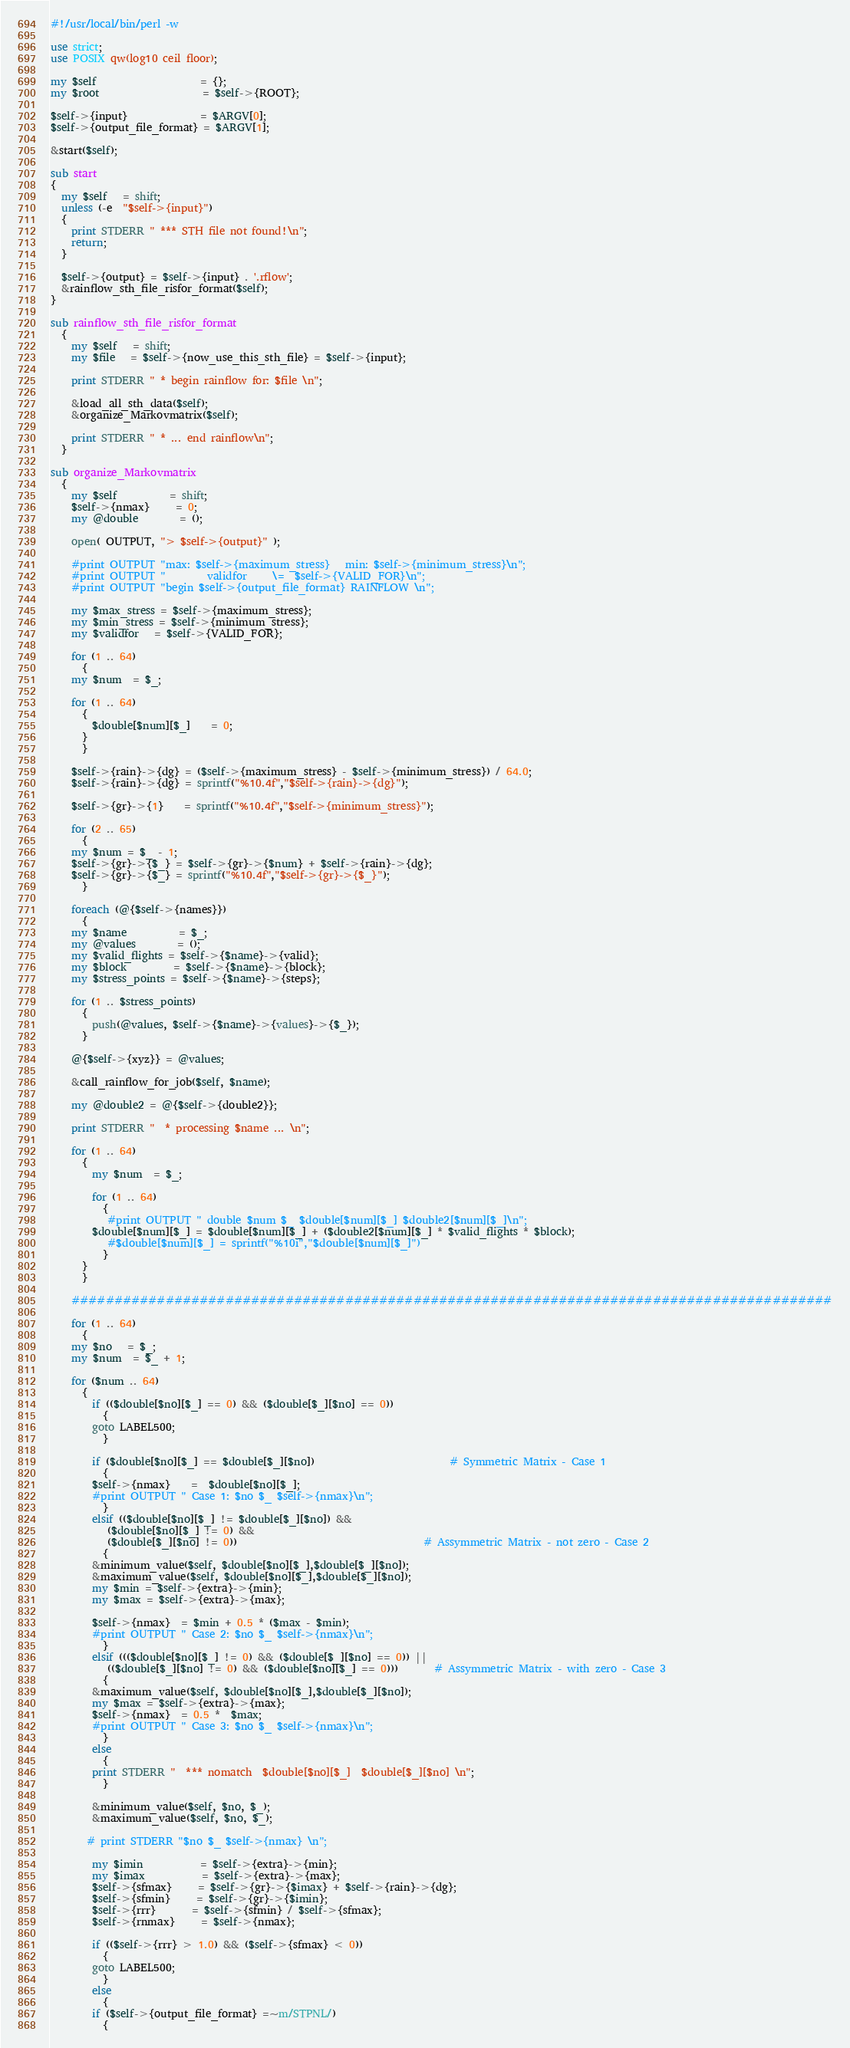Convert code to text. <code><loc_0><loc_0><loc_500><loc_500><_Perl_>#!/usr/local/bin/perl -w

use strict;
use POSIX qw(log10 ceil floor);

my $self                    = {};
my $root                    = $self->{ROOT};

$self->{input}              = $ARGV[0];
$self->{output_file_format} = $ARGV[1];

&start($self);

sub start
{
  my $self   = shift;
  unless (-e  "$self->{input}")
  {
    print STDERR " *** STH file not found!\n";
    return;
  }
  
  $self->{output} = $self->{input} . '.rflow';
  &rainflow_sth_file_risfor_format($self);
}

sub rainflow_sth_file_risfor_format
  {
    my $self   = shift;
    my $file   = $self->{now_use_this_sth_file} = $self->{input};

    print STDERR " * begin rainflow for: $file \n";

    &load_all_sth_data($self);
    &organize_Markovmatrix($self);

    print STDERR " * ... end rainflow\n";
  }

sub organize_Markovmatrix
  {
    my $self          = shift;
    $self->{nmax}     = 0;
    my @double        = ();

    open( OUTPUT, "> $self->{output}" );

    #print OUTPUT "max: $self->{maximum_stress}   min: $self->{minimum_stress}\n";
    #print OUTPUT "        validfor     \=  $self->{VALID_FOR}\n";
    #print OUTPUT "begin $self->{output_file_format} RAINFLOW \n";

    my $max_stress = $self->{maximum_stress};
    my $min_stress = $self->{minimum_stress};
    my $validfor   = $self->{VALID_FOR};

    for (1 .. 64)
      {
	my $num  = $_;

	for (1 .. 64)
	  {
	    $double[$num][$_]    = 0;
	  }
      }

    $self->{rain}->{dg} = ($self->{maximum_stress} - $self->{minimum_stress}) / 64.0;
    $self->{rain}->{dg} = sprintf("%10.4f","$self->{rain}->{dg}");

    $self->{gr}->{1}    = sprintf("%10.4f","$self->{minimum_stress}");

    for (2 .. 65)
      {
	my $num = $_ - 1;
	$self->{gr}->{$_} = $self->{gr}->{$num} + $self->{rain}->{dg};
	$self->{gr}->{$_} = sprintf("%10.4f","$self->{gr}->{$_}");
      }

    foreach (@{$self->{names}})
      {
	my $name          = $_;
	my @values        = ();
	my $valid_flights = $self->{$name}->{valid};
	my $block         = $self->{$name}->{block};
	my $stress_points = $self->{$name}->{steps};

	for (1 .. $stress_points)
	  {
	    push(@values, $self->{$name}->{values}->{$_});
	  }

 	@{$self->{xyz}} = @values;

	&call_rainflow_for_job($self, $name);

	my @double2 = @{$self->{double2}};

	print STDERR "  * processing $name ... \n";

	for (1 .. 64)
	  {
	    my $num  = $_;

	    for (1 .. 64)
	      {
	       #print OUTPUT " double $num $_ $double[$num][$_] $double2[$num][$_]\n";
		$double[$num][$_] = $double[$num][$_] + ($double2[$num][$_] * $valid_flights * $block);
	       #$double[$num][$_] = sprintf("%10i","$double[$num][$_]")
	      }
	  }
      }

    #########################################################################################

    for (1 .. 64)
      {
	my $no   = $_;
	my $num  = $_ + 1;

	for ($num .. 64)
	  {
	    if (($double[$no][$_] == 0) && ($double[$_][$no] == 0))
	      {
		goto LABEL500;
	      }

	    if ($double[$no][$_] == $double[$_][$no])                          # Symmetric Matrix - Case 1
	      {
		$self->{nmax}    =  $double[$no][$_];
		#print OUTPUT " Case 1: $no $_ $self->{nmax}\n";
	      }
	    elsif (($double[$no][$_] != $double[$_][$no]) && 
 		   ($double[$no][$_] != 0) &&
		   ($double[$_][$no] != 0))                                    # Assymmetric Matrix - not zero - Case 2
	      {	
		&minimum_value($self, $double[$no][$_],$double[$_][$no]);
		&maximum_value($self, $double[$no][$_],$double[$_][$no]);
		my $min = $self->{extra}->{min};
		my $max = $self->{extra}->{max};

		$self->{nmax}  = $min + 0.5 * ($max - $min);
		#print OUTPUT " Case 2: $no $_ $self->{nmax}\n";
	      }
	    elsif ((($double[$no][$_] != 0) && ($double[$_][$no] == 0)) ||
		   (($double[$_][$no] != 0) && ($double[$no][$_] == 0)))       # Assymmetric Matrix - with zero - Case 3
	      {
		&maximum_value($self, $double[$no][$_],$double[$_][$no]);
		my $max = $self->{extra}->{max};
		$self->{nmax}  = 0.5 *  $max;
		#print OUTPUT " Case 3: $no $_ $self->{nmax}\n";
	      }
	    else 
	      {
		print STDERR "  *** nomatch  $double[$no][$_]  $double[$_][$no] \n";
	      }

	    &minimum_value($self, $no, $_);
	    &maximum_value($self, $no, $_);

	   # print STDERR "$no $_ $self->{nmax} \n";

	    my $imin           = $self->{extra}->{min};
	    my $imax           = $self->{extra}->{max};
	    $self->{sfmax}     = $self->{gr}->{$imax} + $self->{rain}->{dg};
	    $self->{sfmin}     = $self->{gr}->{$imin};
	    $self->{rrr}       = $self->{sfmin} / $self->{sfmax};
	    $self->{rnmax}     = $self->{nmax};

	    if (($self->{rrr} > 1.0) && ($self->{sfmax} < 0))
	      {
		goto LABEL500;
	      }
	    else 
	      {
		if ($self->{output_file_format} =~m/STPNL/)
		  {</code> 